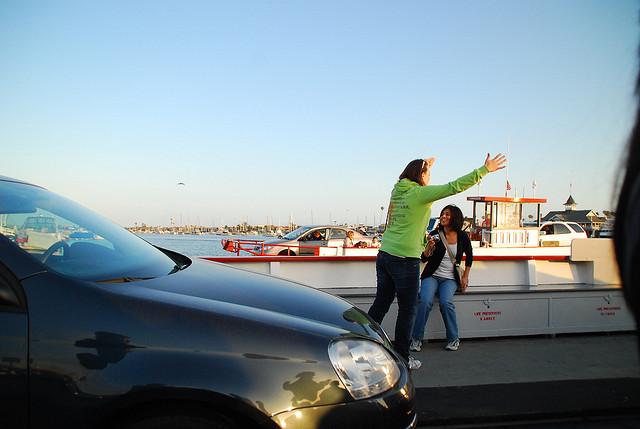What is the color of the car?
Concise answer only. Black. Are both women wearing jeans?
Keep it brief. Yes. What color is the standing women's shirt?
Write a very short answer. Green. 